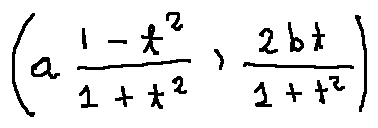Convert formula to latex. <formula><loc_0><loc_0><loc_500><loc_500>( a \frac { 1 - t ^ { 2 } } { 1 + t ^ { 2 } } , \frac { 2 b t } { 1 + t ^ { 2 } } )</formula> 